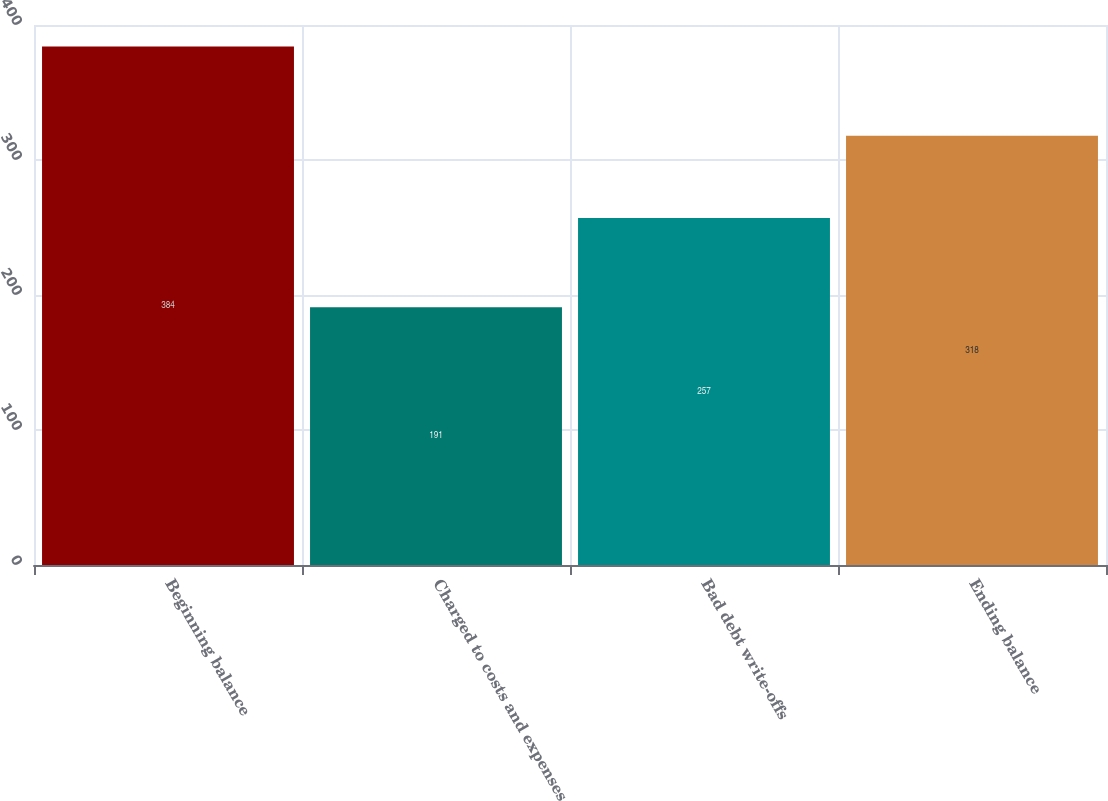Convert chart. <chart><loc_0><loc_0><loc_500><loc_500><bar_chart><fcel>Beginning balance<fcel>Charged to costs and expenses<fcel>Bad debt write-offs<fcel>Ending balance<nl><fcel>384<fcel>191<fcel>257<fcel>318<nl></chart> 